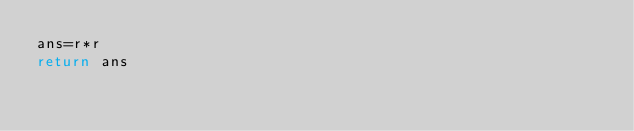Convert code to text. <code><loc_0><loc_0><loc_500><loc_500><_Python_>ans=r*r
return ans</code> 